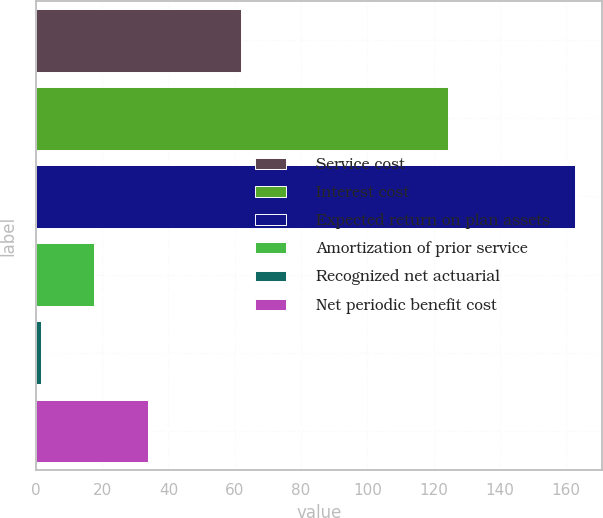<chart> <loc_0><loc_0><loc_500><loc_500><bar_chart><fcel>Service cost<fcel>Interest cost<fcel>Expected return on plan assets<fcel>Amortization of prior service<fcel>Recognized net actuarial<fcel>Net periodic benefit cost<nl><fcel>62<fcel>124.3<fcel>162.8<fcel>17.63<fcel>1.5<fcel>33.76<nl></chart> 